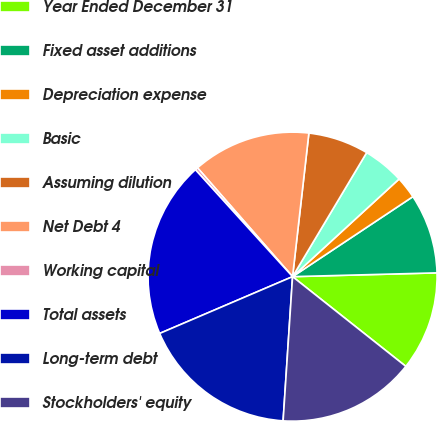Convert chart to OTSL. <chart><loc_0><loc_0><loc_500><loc_500><pie_chart><fcel>Year Ended December 31<fcel>Fixed asset additions<fcel>Depreciation expense<fcel>Basic<fcel>Assuming dilution<fcel>Net Debt 4<fcel>Working capital<fcel>Total assets<fcel>Long-term debt<fcel>Stockholders' equity<nl><fcel>11.08%<fcel>8.92%<fcel>2.47%<fcel>4.62%<fcel>6.77%<fcel>13.23%<fcel>0.31%<fcel>19.69%<fcel>17.53%<fcel>15.38%<nl></chart> 